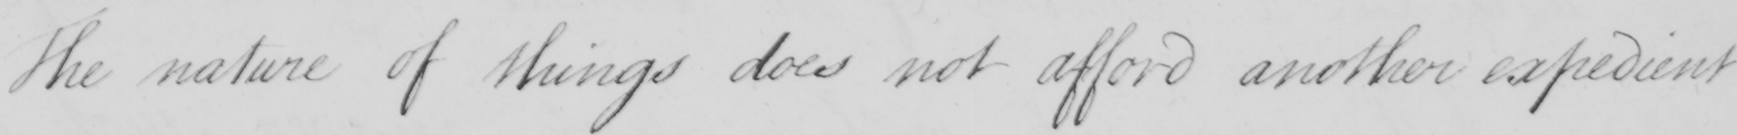Please provide the text content of this handwritten line. The nature of things does not afford another expedient 